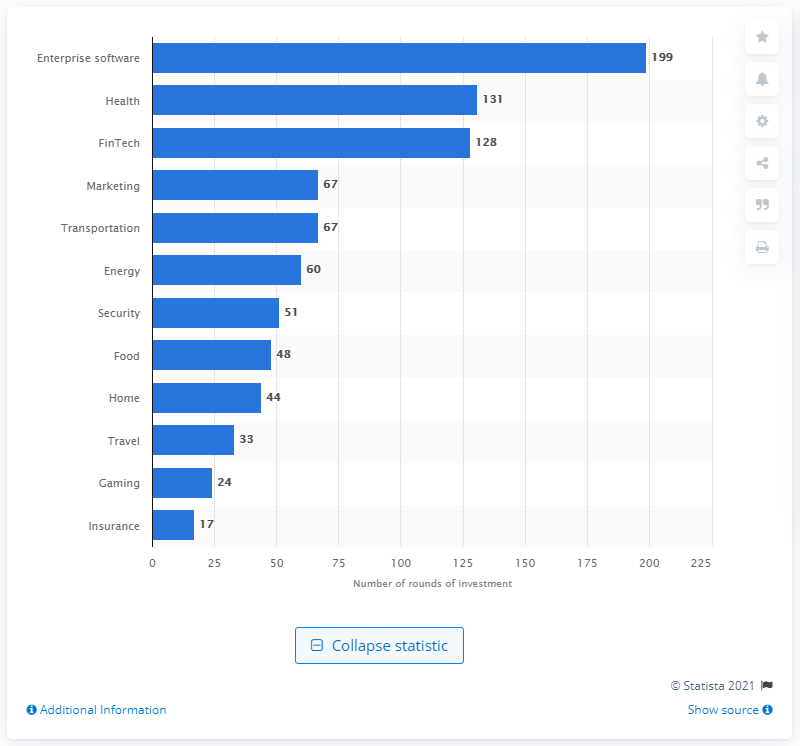Indicate a few pertinent items in this graphic. In the first quarter of 2019, a total of 131 investment rounds were held in the health and enterprise software industries. 